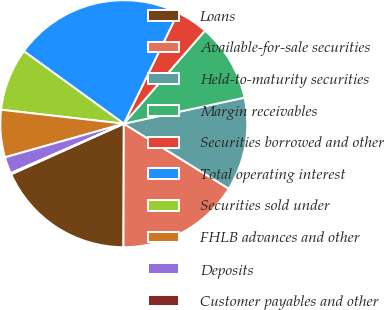Convert chart. <chart><loc_0><loc_0><loc_500><loc_500><pie_chart><fcel>Loans<fcel>Available-for-sale securities<fcel>Held-to-maturity securities<fcel>Margin receivables<fcel>Securities borrowed and other<fcel>Total operating interest<fcel>Securities sold under<fcel>FHLB advances and other<fcel>Deposits<fcel>Customer payables and other<nl><fcel>18.23%<fcel>16.22%<fcel>12.21%<fcel>10.2%<fcel>4.18%<fcel>22.25%<fcel>8.19%<fcel>6.19%<fcel>2.17%<fcel>0.16%<nl></chart> 